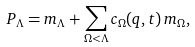<formula> <loc_0><loc_0><loc_500><loc_500>P _ { \Lambda } = m _ { \Lambda } + \sum _ { \Omega < \Lambda } c _ { \Omega } ( q , t ) \, m _ { \Omega } ,</formula> 